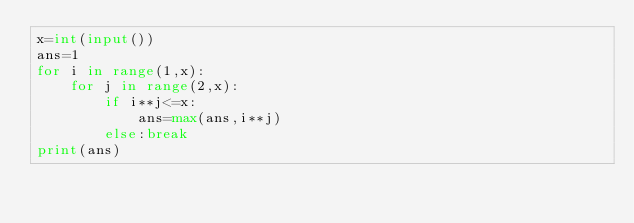Convert code to text. <code><loc_0><loc_0><loc_500><loc_500><_Python_>x=int(input())
ans=1
for i in range(1,x):
    for j in range(2,x):
        if i**j<=x:
            ans=max(ans,i**j)
        else:break
print(ans)</code> 